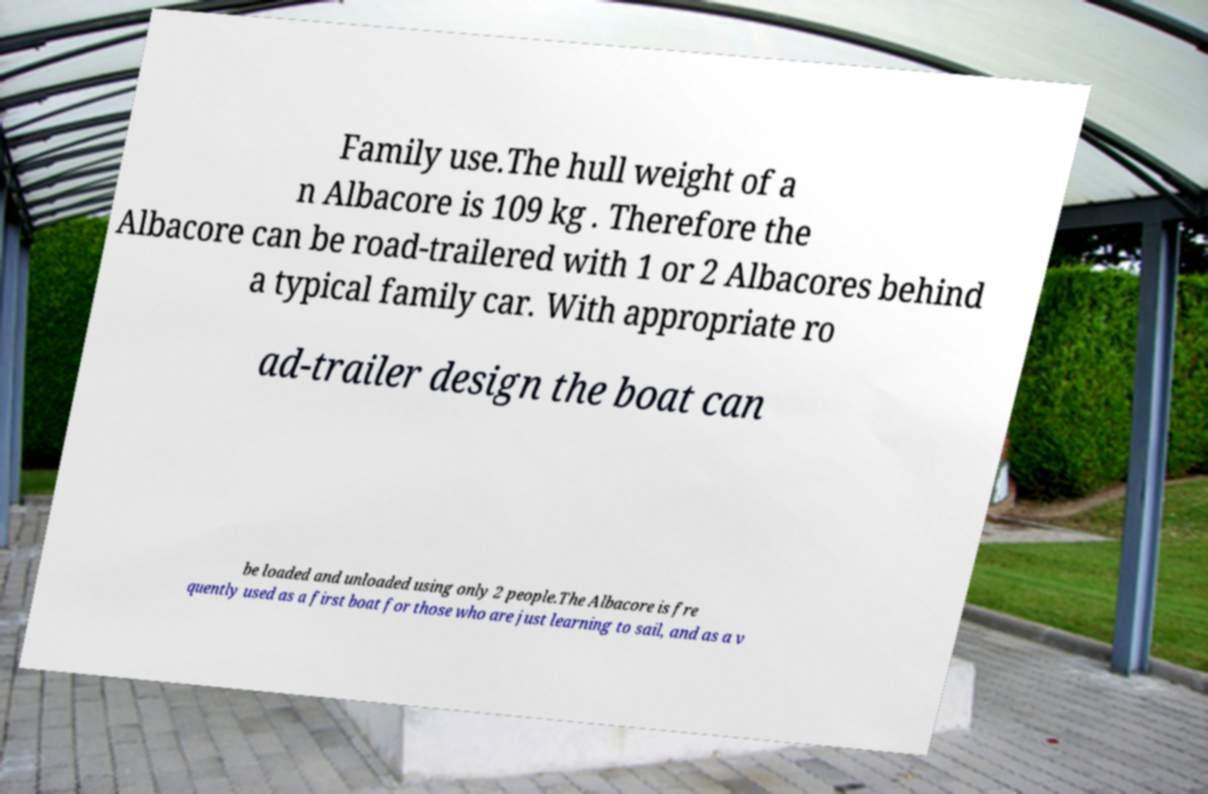Can you read and provide the text displayed in the image?This photo seems to have some interesting text. Can you extract and type it out for me? Family use.The hull weight of a n Albacore is 109 kg . Therefore the Albacore can be road-trailered with 1 or 2 Albacores behind a typical family car. With appropriate ro ad-trailer design the boat can be loaded and unloaded using only 2 people.The Albacore is fre quently used as a first boat for those who are just learning to sail, and as a v 